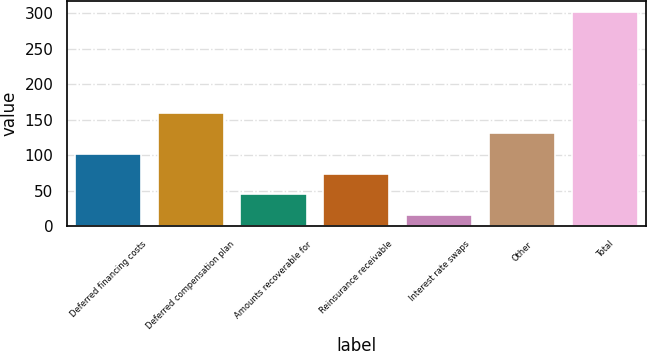Convert chart. <chart><loc_0><loc_0><loc_500><loc_500><bar_chart><fcel>Deferred financing costs<fcel>Deferred compensation plan<fcel>Amounts recoverable for<fcel>Reinsurance receivable<fcel>Interest rate swaps<fcel>Other<fcel>Total<nl><fcel>102.12<fcel>159.2<fcel>45.04<fcel>73.58<fcel>16.5<fcel>130.66<fcel>301.9<nl></chart> 